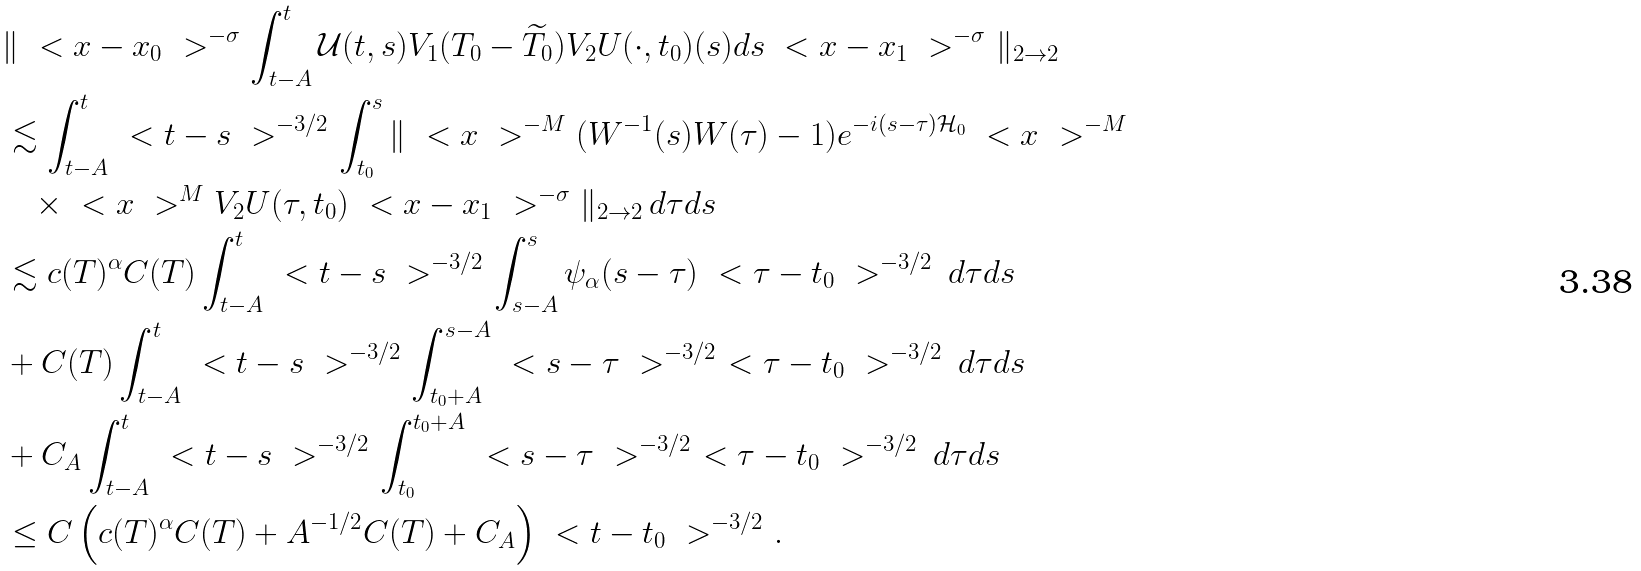Convert formula to latex. <formula><loc_0><loc_0><loc_500><loc_500>& \| \ < x - x _ { 0 } \ > ^ { - \sigma } \int _ { t - A } ^ { t } \mathcal { U } ( t , s ) V _ { 1 } ( { T } _ { 0 } - \widetilde { T } _ { 0 } ) V _ { 2 } U ( \cdot , t _ { 0 } ) ( s ) d s \ < x - x _ { 1 } \ > ^ { - \sigma } \| _ { 2 \to 2 } \\ & \lesssim \int _ { t - A } ^ { t } \ < t - s \ > ^ { - 3 / 2 } \int _ { t _ { 0 } } ^ { s } \| \ < x \ > ^ { - M } ( W ^ { - 1 } ( s ) W ( \tau ) - 1 ) e ^ { - i ( s - \tau ) \mathcal { H } _ { 0 } } \ < x \ > ^ { - M } \\ & \quad \times \ < x \ > ^ { M } V _ { 2 } U ( \tau , t _ { 0 } ) \ < x - x _ { 1 } \ > ^ { - \sigma } \| _ { 2 \to 2 } \, d \tau d s \\ & \lesssim c ( T ) ^ { \alpha } C ( T ) \int _ { t - A } ^ { t } \ < t - s \ > ^ { - 3 / 2 } \int _ { s - A } ^ { s } \psi _ { \alpha } ( s - \tau ) \ < \tau - t _ { 0 } \ > ^ { - 3 / 2 } \, d \tau d s \\ & + C ( T ) \int _ { t - A } ^ { t } \ < t - s \ > ^ { - 3 / 2 } \int _ { t _ { 0 } + A } ^ { s - A } \ < s - \tau \ > ^ { - 3 / 2 } \ < \tau - t _ { 0 } \ > ^ { - 3 / 2 } \, d \tau d s \\ & + C _ { A } \int _ { t - A } ^ { t } \ < t - s \ > ^ { - 3 / 2 } \int _ { t _ { 0 } } ^ { t _ { 0 } + A } \ < s - \tau \ > ^ { - 3 / 2 } \ < \tau - t _ { 0 } \ > ^ { - 3 / 2 } \, d \tau d s \\ & \leq C \left ( c ( T ) ^ { \alpha } C ( T ) + A ^ { - 1 / 2 } C ( T ) + C _ { A } \right ) \ < t - t _ { 0 } \ > ^ { - 3 / 2 } .</formula> 